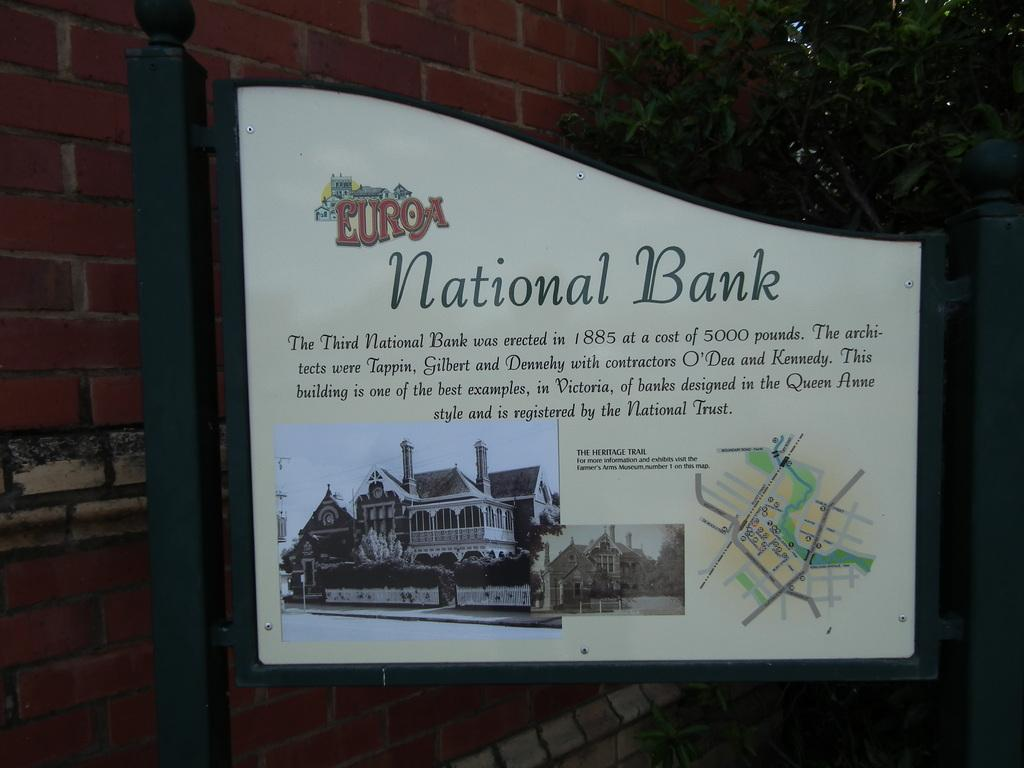Provide a one-sentence caption for the provided image. the entrance board which shows the details of Euroa National Bank with the oldest picture and  location map. 